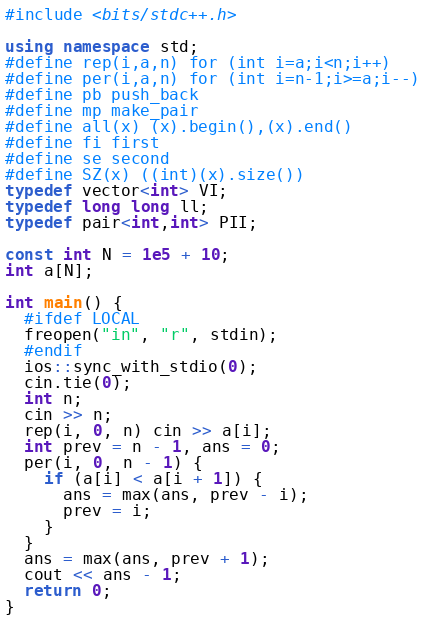Convert code to text. <code><loc_0><loc_0><loc_500><loc_500><_C++_>#include <bits/stdc++.h>

using namespace std;
#define rep(i,a,n) for (int i=a;i<n;i++)
#define per(i,a,n) for (int i=n-1;i>=a;i--)
#define pb push_back
#define mp make_pair
#define all(x) (x).begin(),(x).end()
#define fi first
#define se second
#define SZ(x) ((int)(x).size())
typedef vector<int> VI;
typedef long long ll;
typedef pair<int,int> PII;

const int N = 1e5 + 10;
int a[N];

int main() {
  #ifdef LOCAL
  freopen("in", "r", stdin);
  #endif
  ios::sync_with_stdio(0);
  cin.tie(0);
  int n;
  cin >> n;
  rep(i, 0, n) cin >> a[i];
  int prev = n - 1, ans = 0;
  per(i, 0, n - 1) {
    if (a[i] < a[i + 1]) {
      ans = max(ans, prev - i);
      prev = i;
    }
  }
  ans = max(ans, prev + 1);
  cout << ans - 1;
  return 0;
}
</code> 